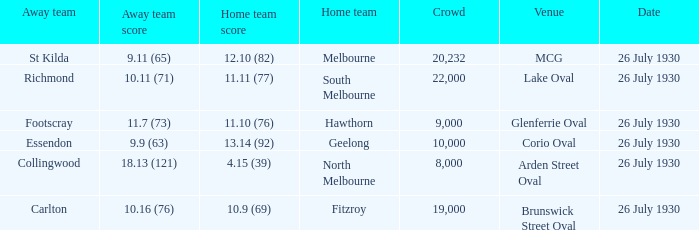Where did Geelong play a home game? Corio Oval. 